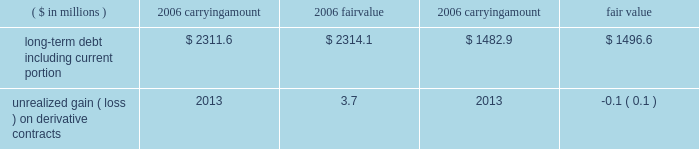Page 78 of 98 notes to consolidated financial statements ball corporation and subsidiaries 17 .
Financial instruments and risk management ( continued ) at december 31 , 2006 , the company had outstanding interest rate swap agreements in europe with notional amounts of 20ac135 million paying fixed rates .
Approximately $ 4 million of net gain associated with these contracts is included in accumulated other comprehensive loss at december 31 , 2006 , of which $ 0.8 million is expected to be recognized in the consolidated statement of earnings during 2007 .
Approximately $ 1.1 million of net gain related to the termination or deselection of hedges is included in accumulated other comprehensive loss at december 31 , 2006 .
The amount recognized in 2006 earnings related to terminated hedges was insignificant .
The fair value of all non-derivative financial instruments approximates their carrying amounts with the exception of long-term debt .
Rates currently available to the company for loans with similar terms and maturities are used to estimate the fair value of long-term debt based on discounted cash flows .
The fair value of derivatives generally reflects the estimated amounts that we would pay or receive upon termination of the contracts at december 31 , 2006 , taking into account any unrealized gains and losses on open contracts. .
Foreign currency exchange rate risk our objective in managing exposure to foreign currency fluctuations is to protect foreign cash flows and earnings from changes associated with foreign currency exchange rate changes through the use of cash flow hedges .
In addition , we manage foreign earnings translation volatility through the use of foreign currency options .
Our foreign currency translation risk results from the european euro , british pound , canadian dollar , polish zloty , serbian dinar , brazilian real , argentine peso and chinese renminbi .
We face currency exposures in our global operations as a result of purchasing raw materials in u.s .
Dollars and , to a lesser extent , in other currencies .
Sales contracts are negotiated with customers to reflect cost changes and , where there is not a foreign exchange pass-through arrangement , the company uses forward and option contracts to manage foreign currency exposures .
Such contracts outstanding at december 31 , 2006 , expire within four years and there are no amounts included in accumulated other comprehensive loss related to these contracts. .
What is the unrealized gain ( in millions ) on the hedges of long-term debt for 2006? 
Computations: (2314.1 - 2311.6)
Answer: 2.5. 